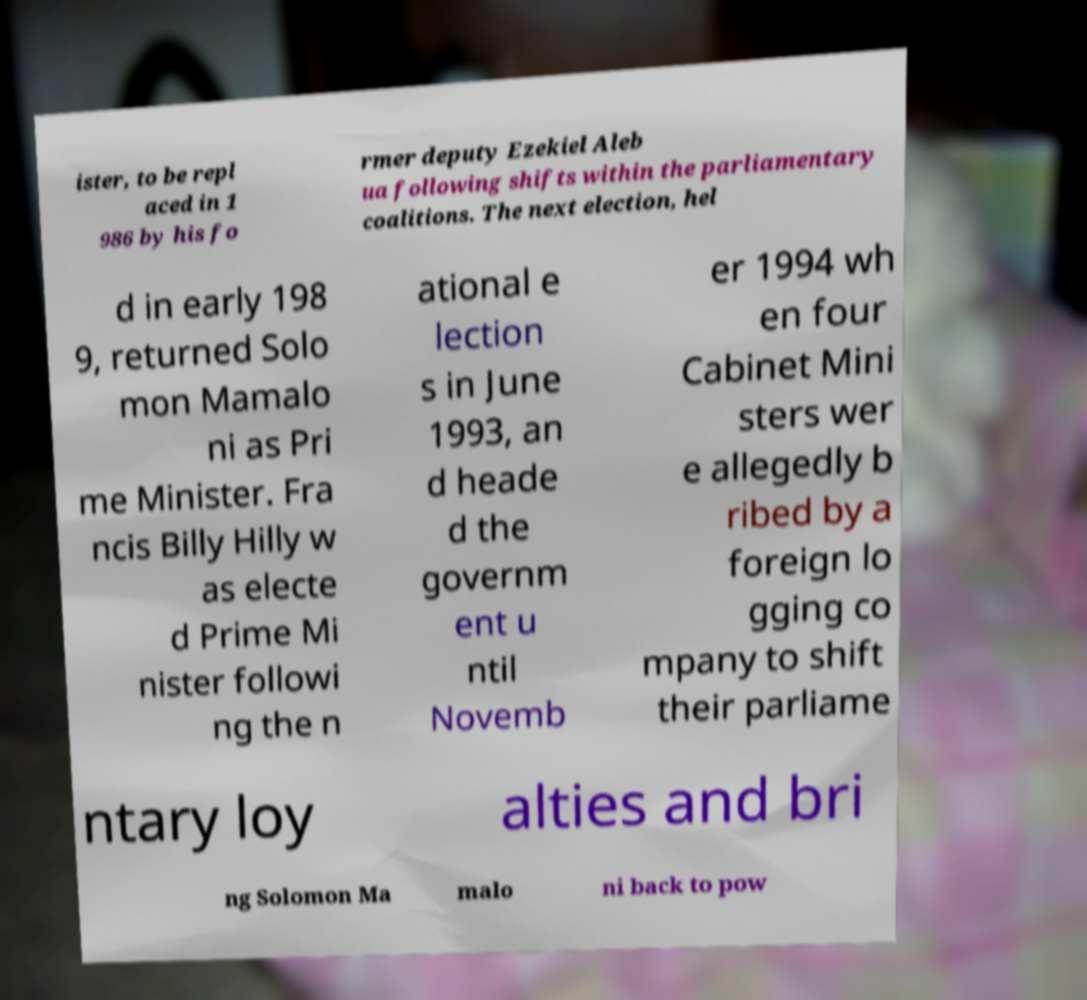Could you assist in decoding the text presented in this image and type it out clearly? ister, to be repl aced in 1 986 by his fo rmer deputy Ezekiel Aleb ua following shifts within the parliamentary coalitions. The next election, hel d in early 198 9, returned Solo mon Mamalo ni as Pri me Minister. Fra ncis Billy Hilly w as electe d Prime Mi nister followi ng the n ational e lection s in June 1993, an d heade d the governm ent u ntil Novemb er 1994 wh en four Cabinet Mini sters wer e allegedly b ribed by a foreign lo gging co mpany to shift their parliame ntary loy alties and bri ng Solomon Ma malo ni back to pow 